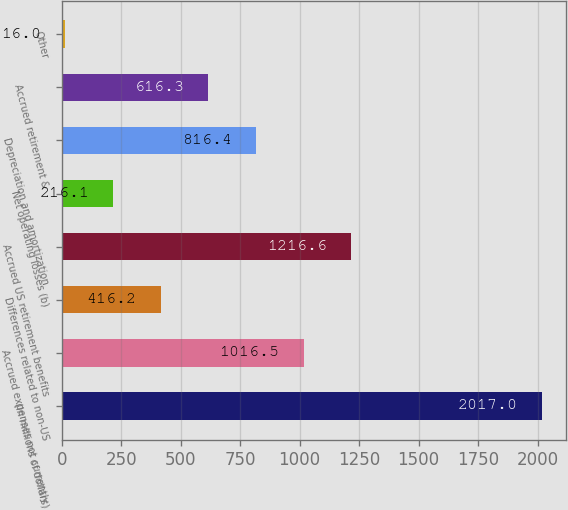Convert chart. <chart><loc_0><loc_0><loc_500><loc_500><bar_chart><fcel>(In millions of dollars)<fcel>Accrued expenses not currently<fcel>Differences related to non-US<fcel>Accrued US retirement benefits<fcel>Net operating losses (b)<fcel>Depreciation and amortization<fcel>Accrued retirement &<fcel>Other<nl><fcel>2017<fcel>1016.5<fcel>416.2<fcel>1216.6<fcel>216.1<fcel>816.4<fcel>616.3<fcel>16<nl></chart> 